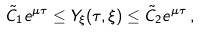Convert formula to latex. <formula><loc_0><loc_0><loc_500><loc_500>\tilde { C } _ { 1 } e ^ { \mu \tau } \leq Y _ { \xi } ( \tau , \xi ) \leq \tilde { C } _ { 2 } e ^ { \mu \tau } \, ,</formula> 